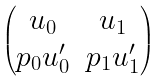Convert formula to latex. <formula><loc_0><loc_0><loc_500><loc_500>\begin{pmatrix} u _ { 0 } & u _ { 1 } \\ p _ { 0 } u _ { 0 } ^ { \prime } & p _ { 1 } u _ { 1 } ^ { \prime } \end{pmatrix}</formula> 